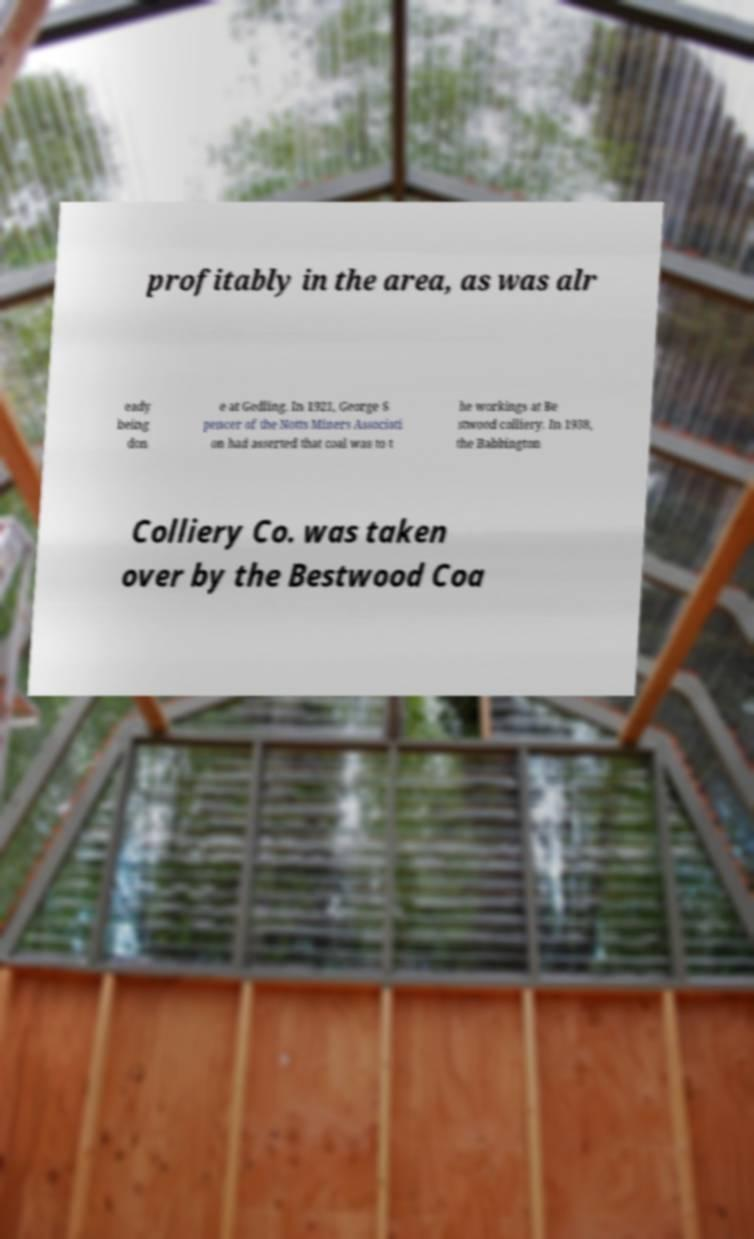What messages or text are displayed in this image? I need them in a readable, typed format. profitably in the area, as was alr eady being don e at Gedling. In 1921, George S pencer of the Notts Miners Associati on had asserted that coal was to t he workings at Be stwood colliery. In 1938, the Babbington Colliery Co. was taken over by the Bestwood Coa 